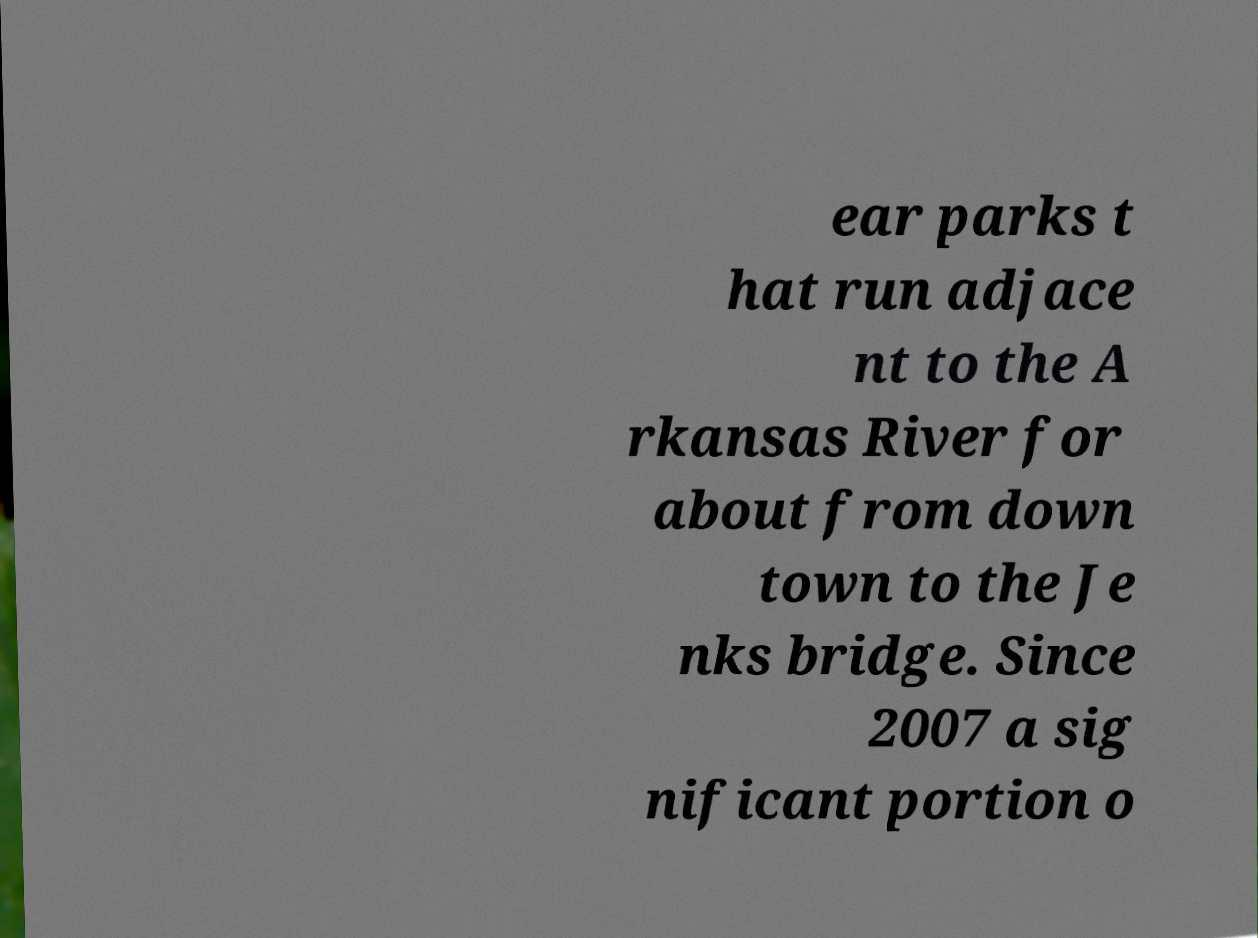Can you accurately transcribe the text from the provided image for me? ear parks t hat run adjace nt to the A rkansas River for about from down town to the Je nks bridge. Since 2007 a sig nificant portion o 